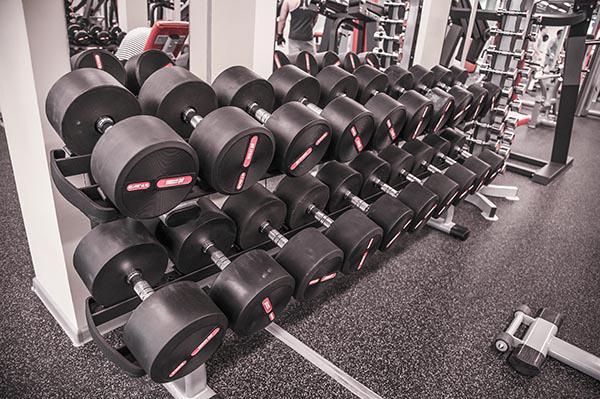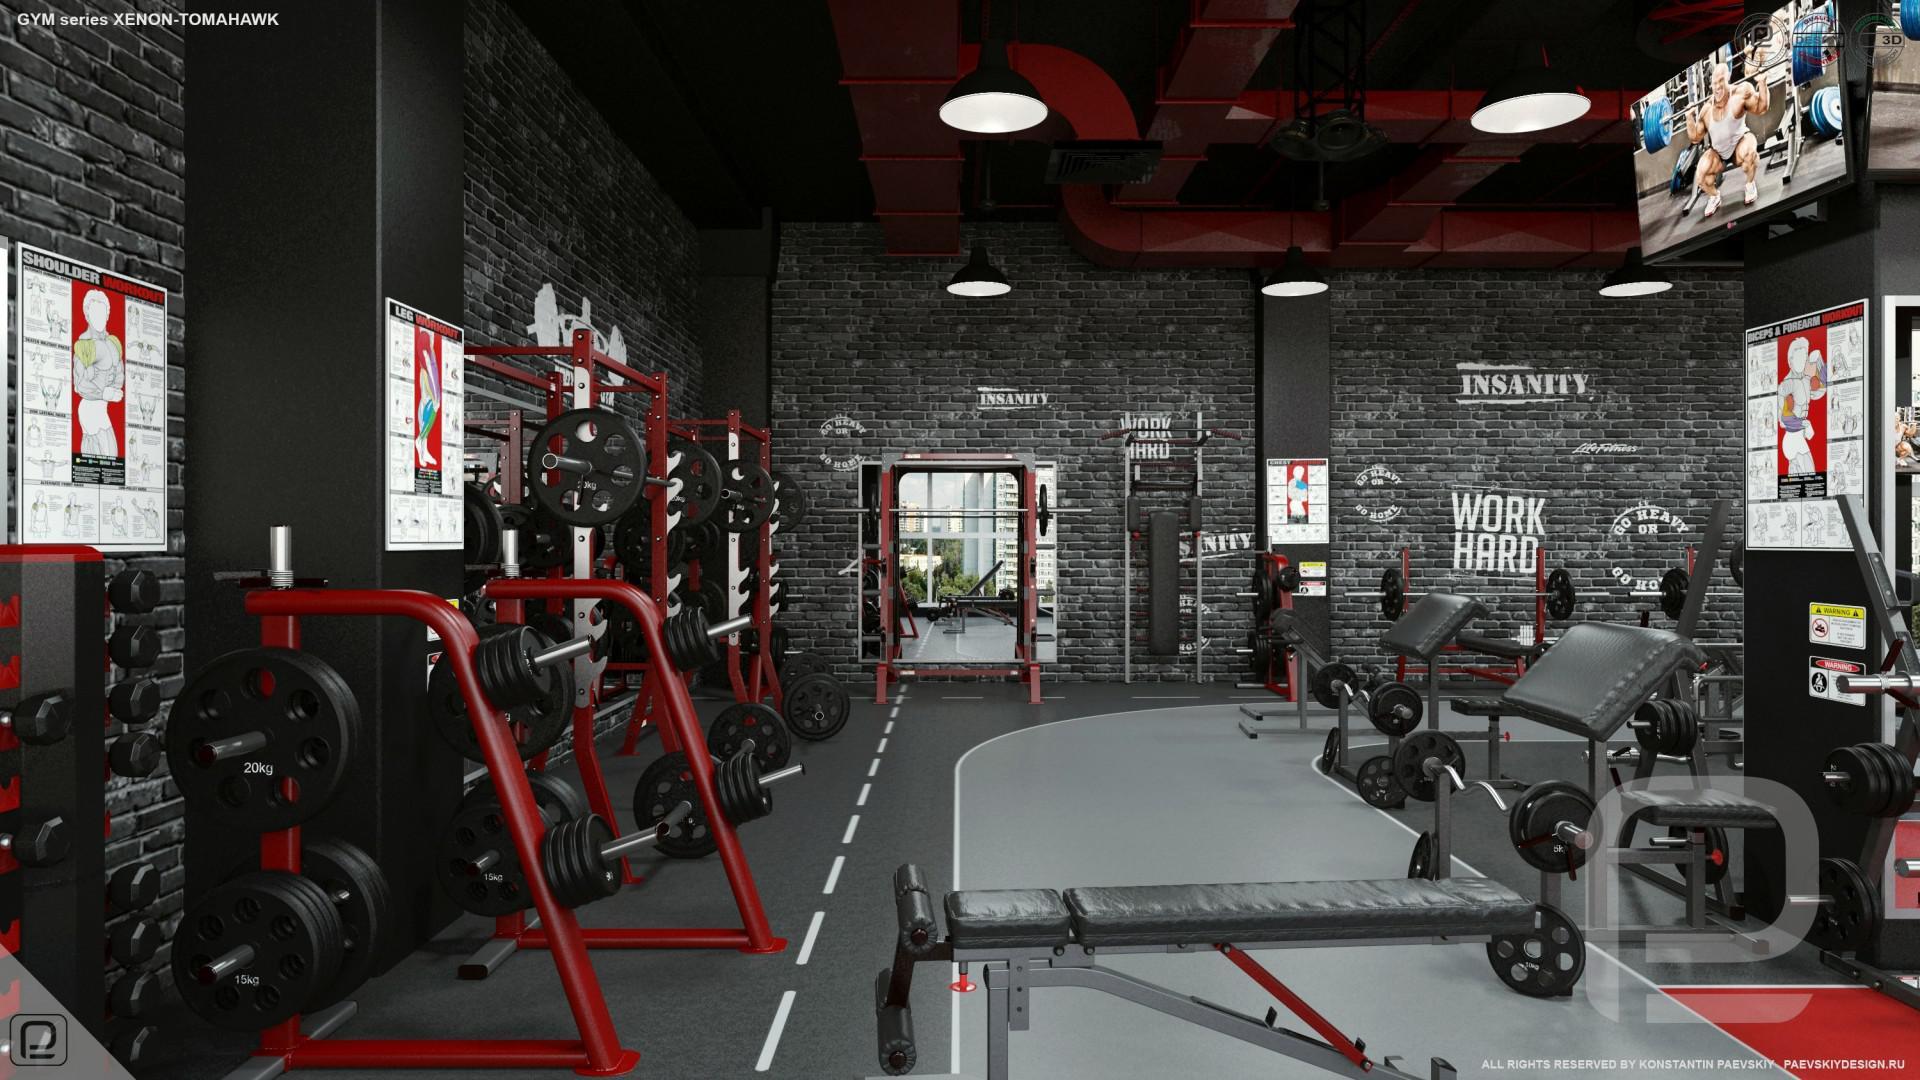The first image is the image on the left, the second image is the image on the right. For the images displayed, is the sentence "One image shows a rack with two angled rows of black dumbbells, and the other image shows a gym with workout equipment and a gray floor." factually correct? Answer yes or no. Yes. 